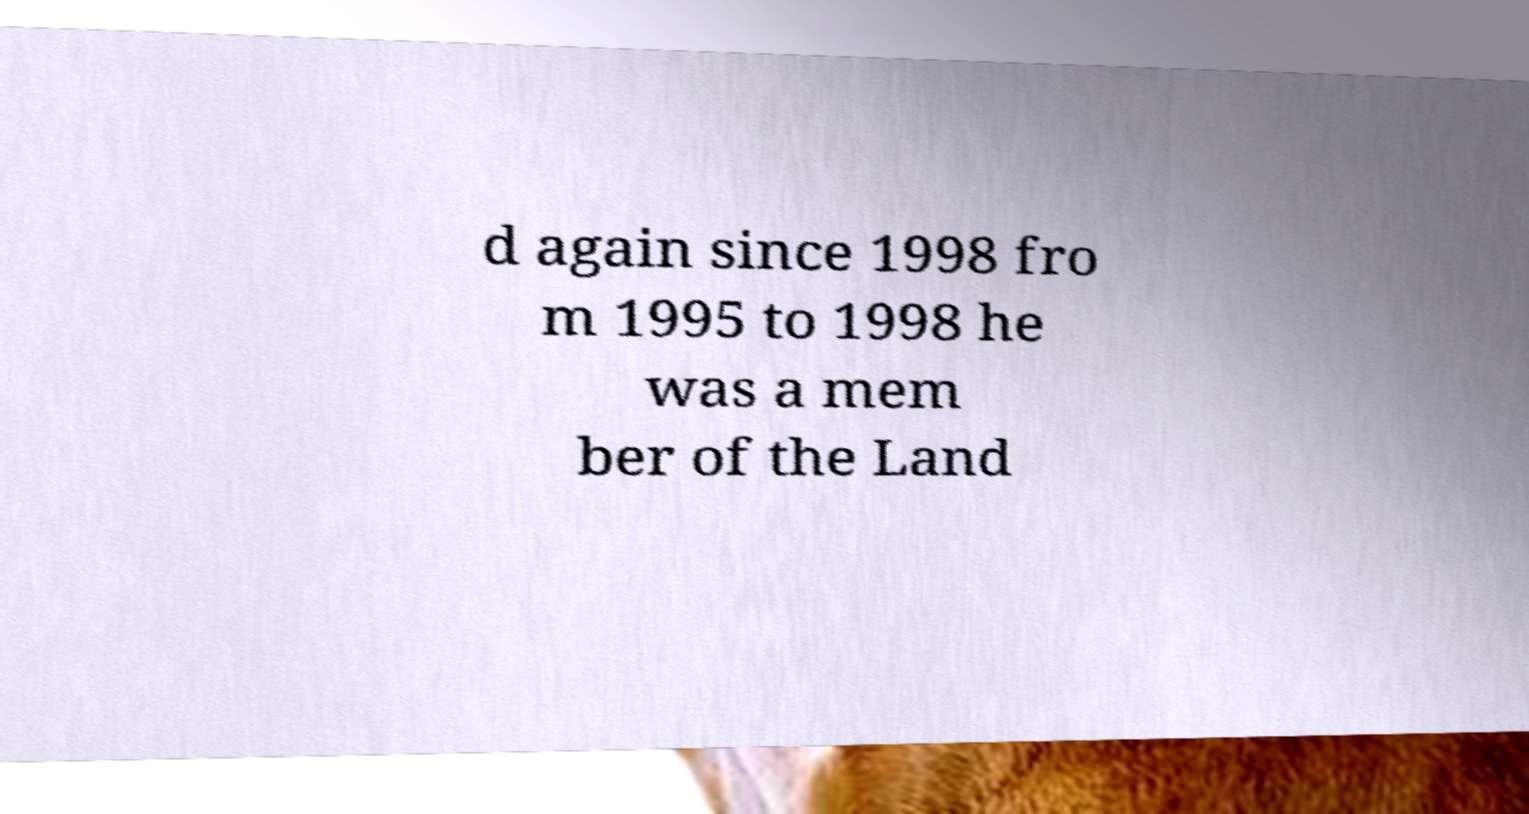Can you read and provide the text displayed in the image?This photo seems to have some interesting text. Can you extract and type it out for me? d again since 1998 fro m 1995 to 1998 he was a mem ber of the Land 